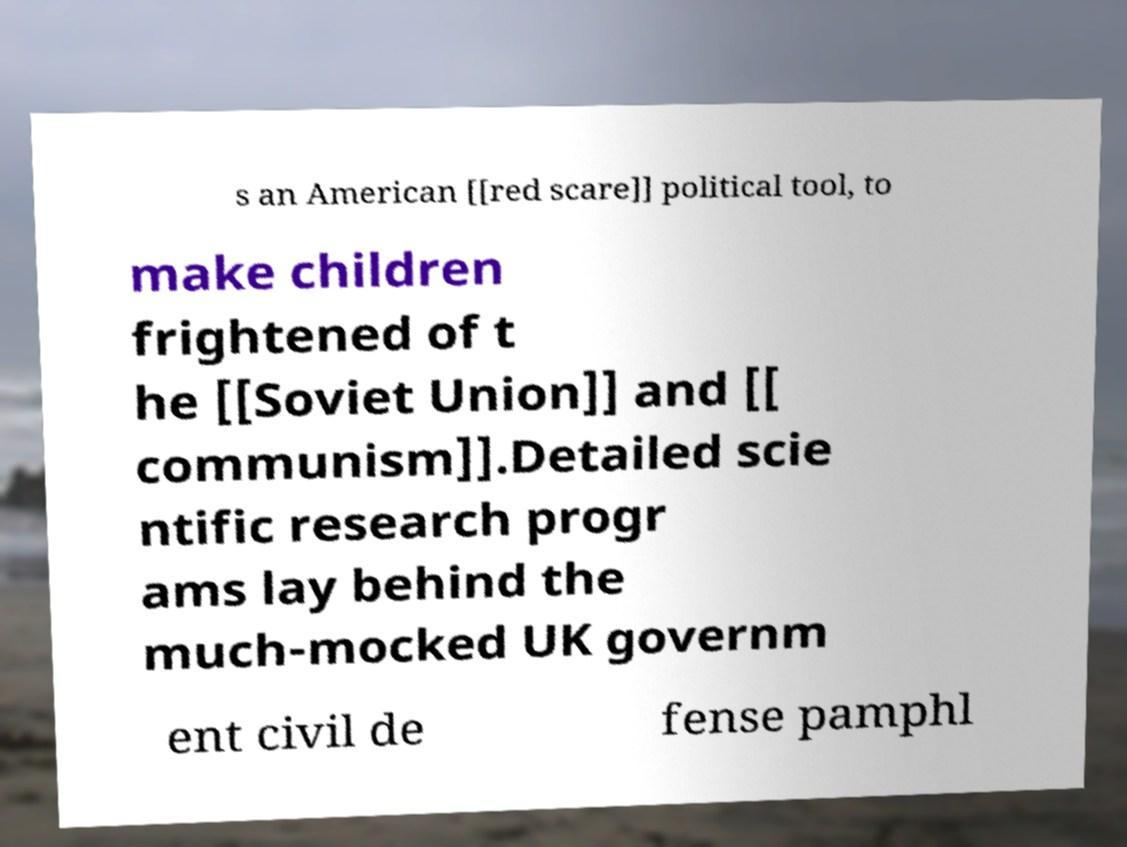For documentation purposes, I need the text within this image transcribed. Could you provide that? s an American [[red scare]] political tool, to make children frightened of t he [[Soviet Union]] and [[ communism]].Detailed scie ntific research progr ams lay behind the much-mocked UK governm ent civil de fense pamphl 